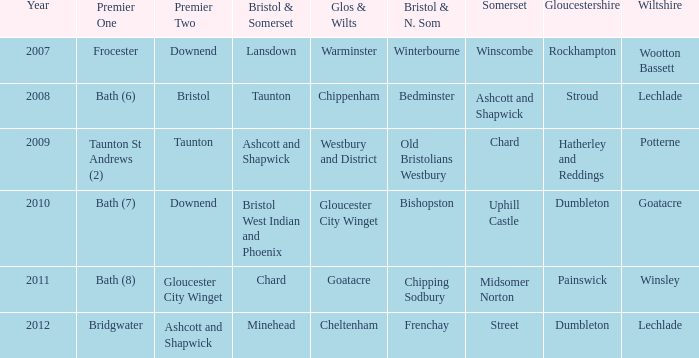What is the year where glos & wilts is gloucester city winget? 2010.0. 